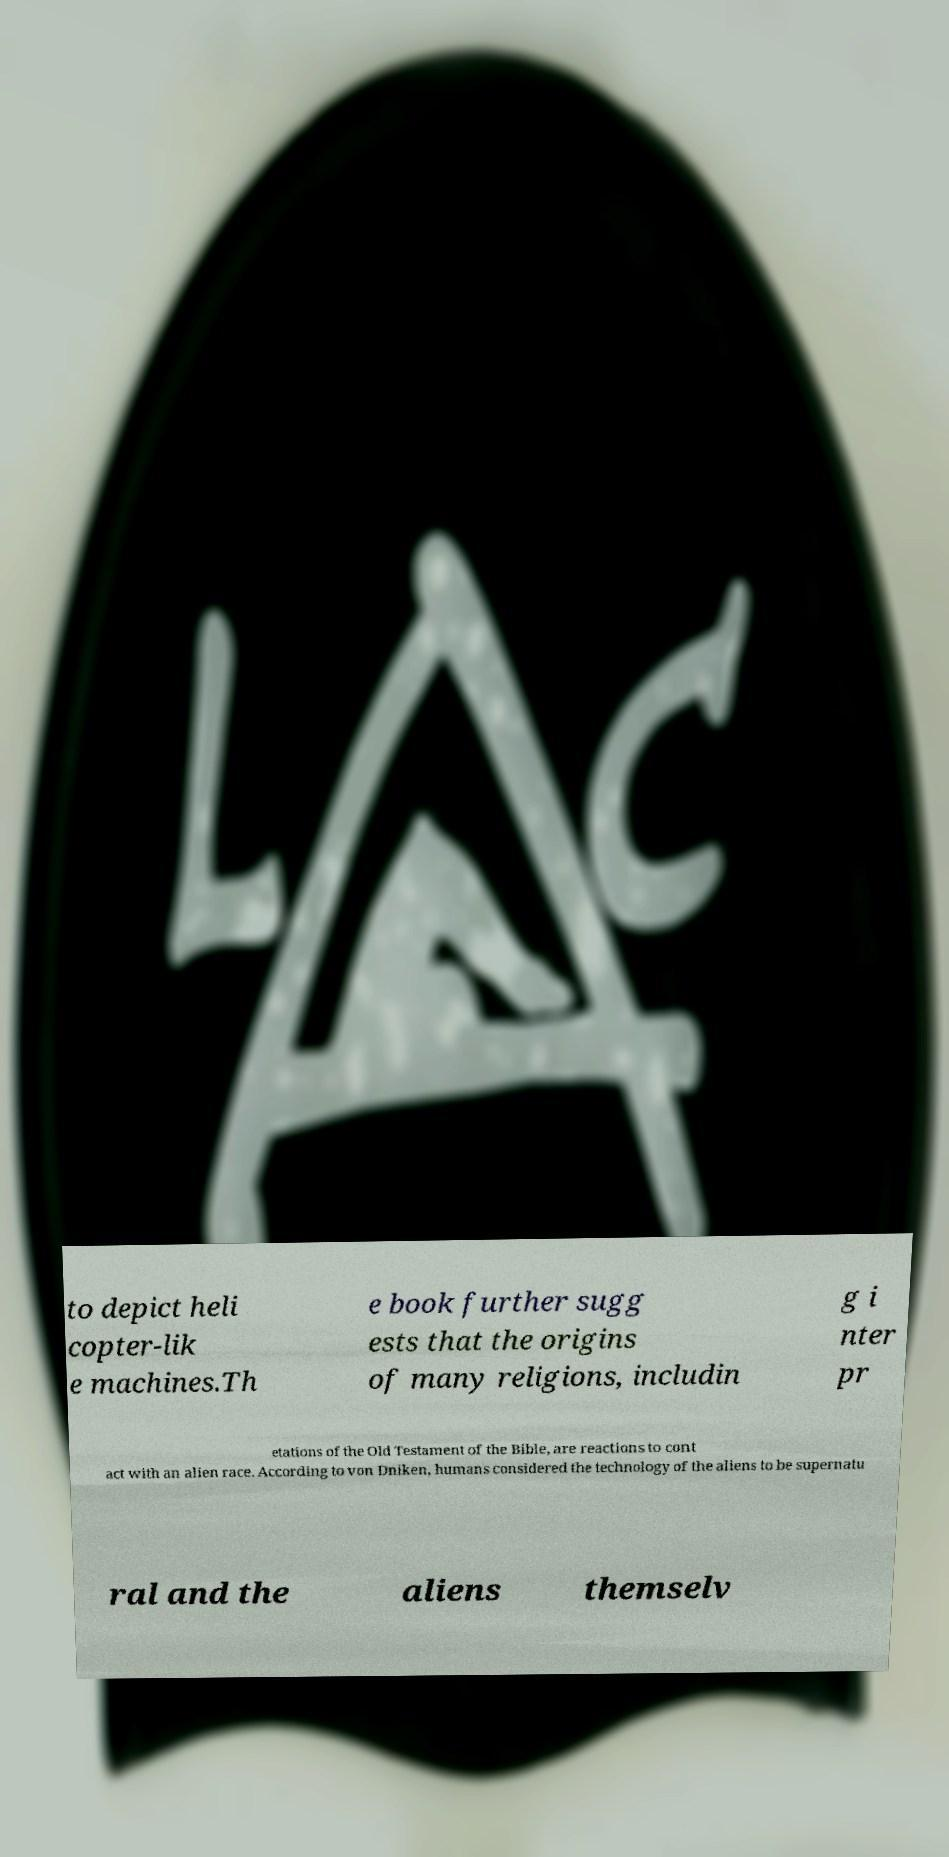What messages or text are displayed in this image? I need them in a readable, typed format. to depict heli copter-lik e machines.Th e book further sugg ests that the origins of many religions, includin g i nter pr etations of the Old Testament of the Bible, are reactions to cont act with an alien race. According to von Dniken, humans considered the technology of the aliens to be supernatu ral and the aliens themselv 